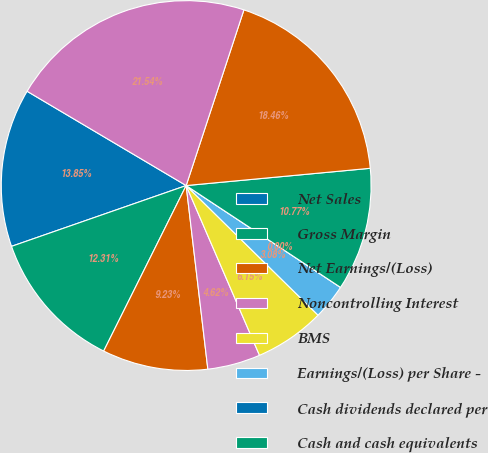<chart> <loc_0><loc_0><loc_500><loc_500><pie_chart><fcel>Net Sales<fcel>Gross Margin<fcel>Net Earnings/(Loss)<fcel>Noncontrolling Interest<fcel>BMS<fcel>Earnings/(Loss) per Share -<fcel>Cash dividends declared per<fcel>Cash and cash equivalents<fcel>Marketable securities^(2)<fcel>Total Assets<nl><fcel>13.85%<fcel>12.31%<fcel>9.23%<fcel>4.62%<fcel>6.15%<fcel>3.08%<fcel>0.0%<fcel>10.77%<fcel>18.46%<fcel>21.54%<nl></chart> 